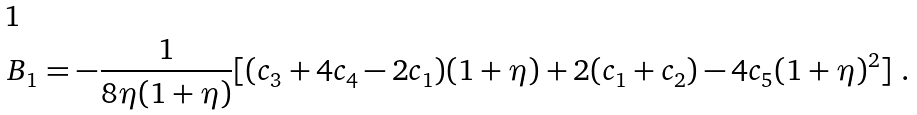Convert formula to latex. <formula><loc_0><loc_0><loc_500><loc_500>B _ { 1 } = - \frac { 1 } { 8 \eta ( 1 + \eta ) } [ ( c _ { 3 } + 4 c _ { 4 } - 2 c _ { 1 } ) ( 1 + \eta ) + 2 ( c _ { 1 } + c _ { 2 } ) - 4 c _ { 5 } ( 1 + \eta ) ^ { 2 } ] \ .</formula> 